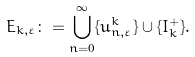<formula> <loc_0><loc_0><loc_500><loc_500>E _ { k , \varepsilon } \colon = \bigcup _ { n = 0 } ^ { \infty } \{ u _ { n , \varepsilon } ^ { k } \} \cup \{ I _ { k } ^ { + } \} .</formula> 